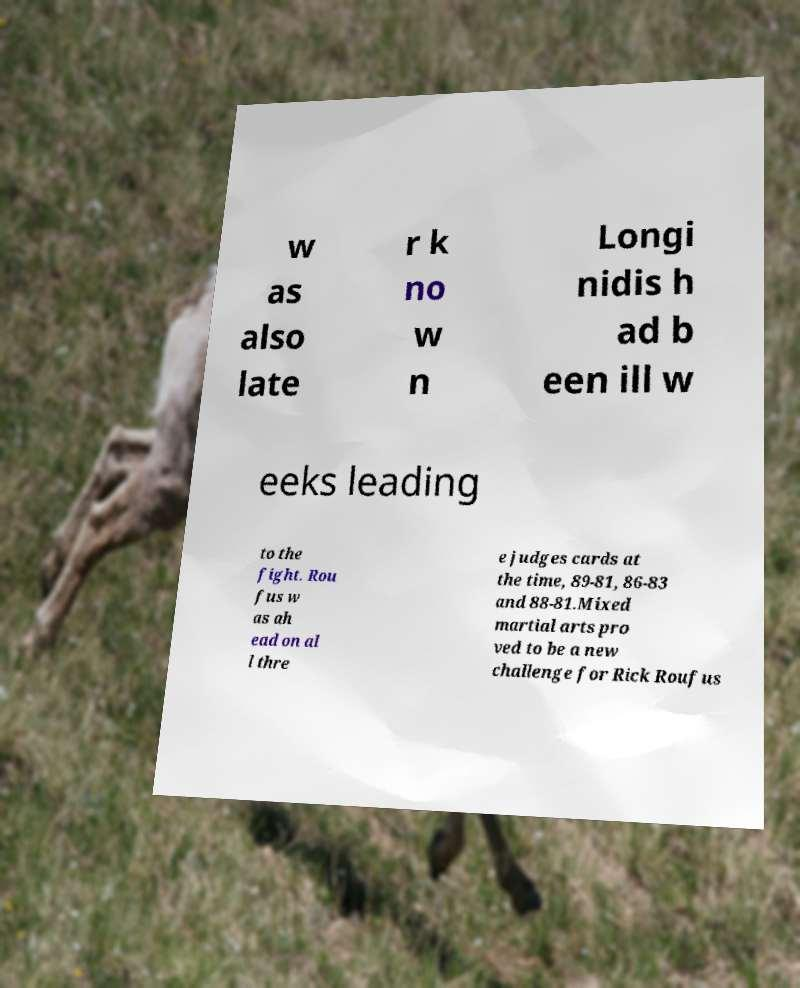Please read and relay the text visible in this image. What does it say? w as also late r k no w n Longi nidis h ad b een ill w eeks leading to the fight. Rou fus w as ah ead on al l thre e judges cards at the time, 89-81, 86-83 and 88-81.Mixed martial arts pro ved to be a new challenge for Rick Roufus 